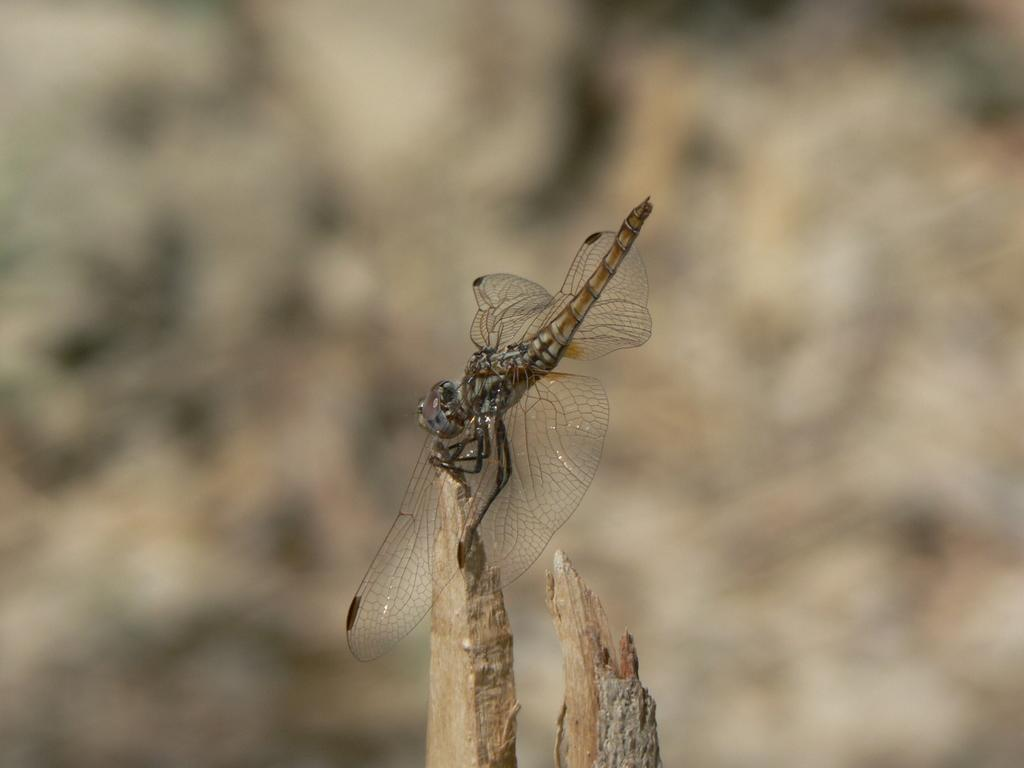What is on the wood in the image? There is a fly on the wood in the image. Can you describe the background of the image? The background of the image is blurry. What type of trousers is the fly wearing in the image? Flies do not wear trousers, as they are insects and do not have the ability to wear clothing. 